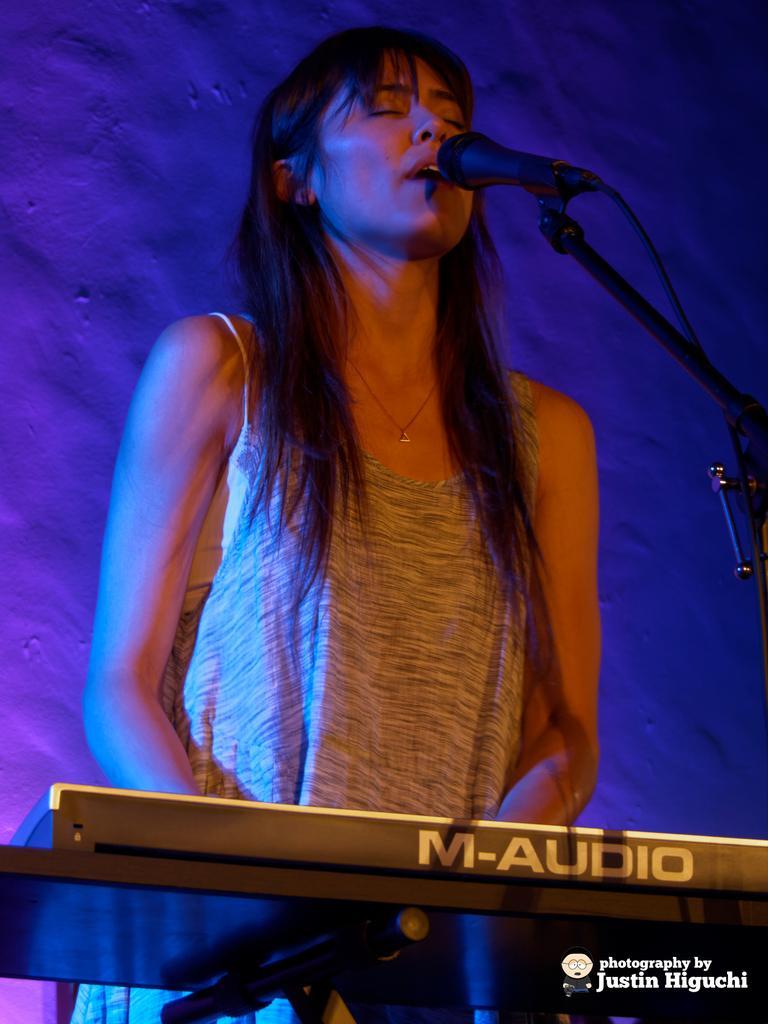How would you summarize this image in a sentence or two? In the picture I can see a woman wearing a grey color dress is standing here and she has closed her eyes. Here I can see a piano and a mic to the stand is in front of her. The background of the image is in blue color. Here I can see the watermark at the bottom right side of the image. 